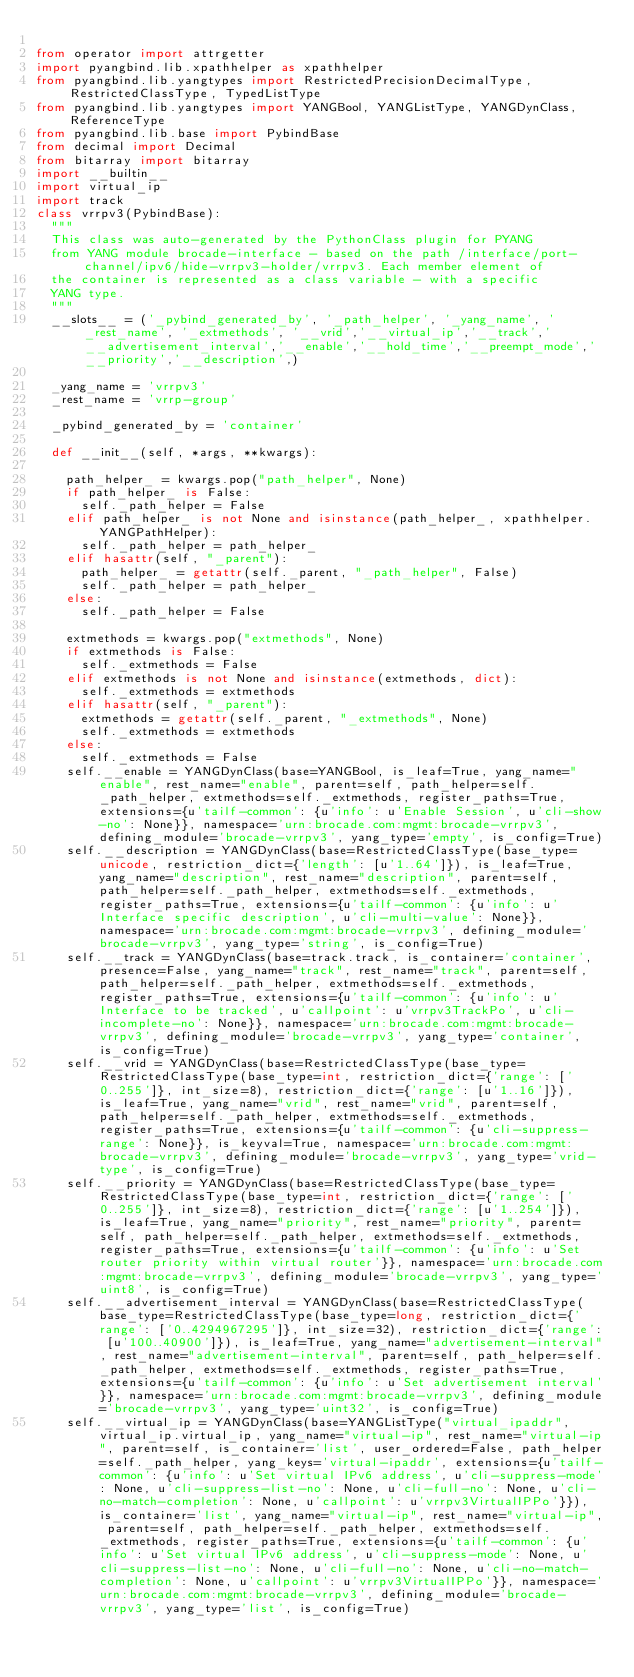Convert code to text. <code><loc_0><loc_0><loc_500><loc_500><_Python_>
from operator import attrgetter
import pyangbind.lib.xpathhelper as xpathhelper
from pyangbind.lib.yangtypes import RestrictedPrecisionDecimalType, RestrictedClassType, TypedListType
from pyangbind.lib.yangtypes import YANGBool, YANGListType, YANGDynClass, ReferenceType
from pyangbind.lib.base import PybindBase
from decimal import Decimal
from bitarray import bitarray
import __builtin__
import virtual_ip
import track
class vrrpv3(PybindBase):
  """
  This class was auto-generated by the PythonClass plugin for PYANG
  from YANG module brocade-interface - based on the path /interface/port-channel/ipv6/hide-vrrpv3-holder/vrrpv3. Each member element of
  the container is represented as a class variable - with a specific
  YANG type.
  """
  __slots__ = ('_pybind_generated_by', '_path_helper', '_yang_name', '_rest_name', '_extmethods', '__vrid','__virtual_ip','__track','__advertisement_interval','__enable','__hold_time','__preempt_mode','__priority','__description',)

  _yang_name = 'vrrpv3'
  _rest_name = 'vrrp-group'

  _pybind_generated_by = 'container'

  def __init__(self, *args, **kwargs):

    path_helper_ = kwargs.pop("path_helper", None)
    if path_helper_ is False:
      self._path_helper = False
    elif path_helper_ is not None and isinstance(path_helper_, xpathhelper.YANGPathHelper):
      self._path_helper = path_helper_
    elif hasattr(self, "_parent"):
      path_helper_ = getattr(self._parent, "_path_helper", False)
      self._path_helper = path_helper_
    else:
      self._path_helper = False

    extmethods = kwargs.pop("extmethods", None)
    if extmethods is False:
      self._extmethods = False
    elif extmethods is not None and isinstance(extmethods, dict):
      self._extmethods = extmethods
    elif hasattr(self, "_parent"):
      extmethods = getattr(self._parent, "_extmethods", None)
      self._extmethods = extmethods
    else:
      self._extmethods = False
    self.__enable = YANGDynClass(base=YANGBool, is_leaf=True, yang_name="enable", rest_name="enable", parent=self, path_helper=self._path_helper, extmethods=self._extmethods, register_paths=True, extensions={u'tailf-common': {u'info': u'Enable Session', u'cli-show-no': None}}, namespace='urn:brocade.com:mgmt:brocade-vrrpv3', defining_module='brocade-vrrpv3', yang_type='empty', is_config=True)
    self.__description = YANGDynClass(base=RestrictedClassType(base_type=unicode, restriction_dict={'length': [u'1..64']}), is_leaf=True, yang_name="description", rest_name="description", parent=self, path_helper=self._path_helper, extmethods=self._extmethods, register_paths=True, extensions={u'tailf-common': {u'info': u'Interface specific description', u'cli-multi-value': None}}, namespace='urn:brocade.com:mgmt:brocade-vrrpv3', defining_module='brocade-vrrpv3', yang_type='string', is_config=True)
    self.__track = YANGDynClass(base=track.track, is_container='container', presence=False, yang_name="track", rest_name="track", parent=self, path_helper=self._path_helper, extmethods=self._extmethods, register_paths=True, extensions={u'tailf-common': {u'info': u'Interface to be tracked', u'callpoint': u'vrrpv3TrackPo', u'cli-incomplete-no': None}}, namespace='urn:brocade.com:mgmt:brocade-vrrpv3', defining_module='brocade-vrrpv3', yang_type='container', is_config=True)
    self.__vrid = YANGDynClass(base=RestrictedClassType(base_type=RestrictedClassType(base_type=int, restriction_dict={'range': ['0..255']}, int_size=8), restriction_dict={'range': [u'1..16']}), is_leaf=True, yang_name="vrid", rest_name="vrid", parent=self, path_helper=self._path_helper, extmethods=self._extmethods, register_paths=True, extensions={u'tailf-common': {u'cli-suppress-range': None}}, is_keyval=True, namespace='urn:brocade.com:mgmt:brocade-vrrpv3', defining_module='brocade-vrrpv3', yang_type='vrid-type', is_config=True)
    self.__priority = YANGDynClass(base=RestrictedClassType(base_type=RestrictedClassType(base_type=int, restriction_dict={'range': ['0..255']}, int_size=8), restriction_dict={'range': [u'1..254']}), is_leaf=True, yang_name="priority", rest_name="priority", parent=self, path_helper=self._path_helper, extmethods=self._extmethods, register_paths=True, extensions={u'tailf-common': {u'info': u'Set router priority within virtual router'}}, namespace='urn:brocade.com:mgmt:brocade-vrrpv3', defining_module='brocade-vrrpv3', yang_type='uint8', is_config=True)
    self.__advertisement_interval = YANGDynClass(base=RestrictedClassType(base_type=RestrictedClassType(base_type=long, restriction_dict={'range': ['0..4294967295']}, int_size=32), restriction_dict={'range': [u'100..40900']}), is_leaf=True, yang_name="advertisement-interval", rest_name="advertisement-interval", parent=self, path_helper=self._path_helper, extmethods=self._extmethods, register_paths=True, extensions={u'tailf-common': {u'info': u'Set advertisement interval'}}, namespace='urn:brocade.com:mgmt:brocade-vrrpv3', defining_module='brocade-vrrpv3', yang_type='uint32', is_config=True)
    self.__virtual_ip = YANGDynClass(base=YANGListType("virtual_ipaddr",virtual_ip.virtual_ip, yang_name="virtual-ip", rest_name="virtual-ip", parent=self, is_container='list', user_ordered=False, path_helper=self._path_helper, yang_keys='virtual-ipaddr', extensions={u'tailf-common': {u'info': u'Set virtual IPv6 address', u'cli-suppress-mode': None, u'cli-suppress-list-no': None, u'cli-full-no': None, u'cli-no-match-completion': None, u'callpoint': u'vrrpv3VirtualIPPo'}}), is_container='list', yang_name="virtual-ip", rest_name="virtual-ip", parent=self, path_helper=self._path_helper, extmethods=self._extmethods, register_paths=True, extensions={u'tailf-common': {u'info': u'Set virtual IPv6 address', u'cli-suppress-mode': None, u'cli-suppress-list-no': None, u'cli-full-no': None, u'cli-no-match-completion': None, u'callpoint': u'vrrpv3VirtualIPPo'}}, namespace='urn:brocade.com:mgmt:brocade-vrrpv3', defining_module='brocade-vrrpv3', yang_type='list', is_config=True)</code> 